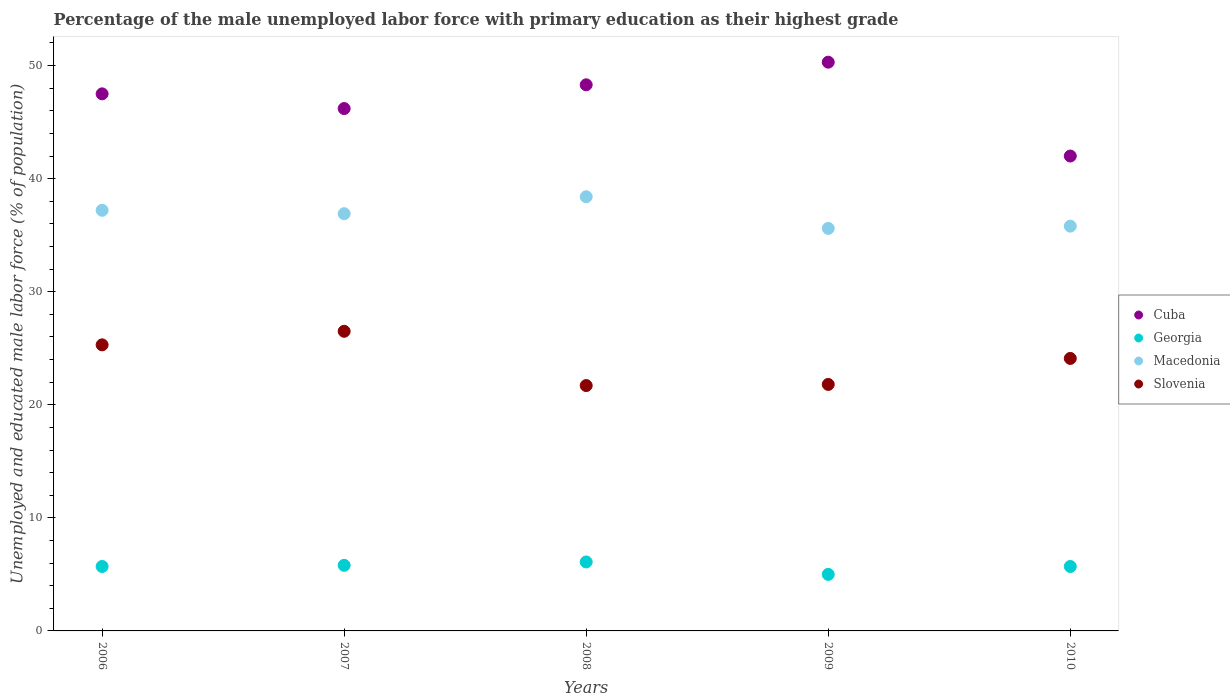How many different coloured dotlines are there?
Your answer should be very brief. 4. What is the percentage of the unemployed male labor force with primary education in Macedonia in 2010?
Offer a very short reply. 35.8. Across all years, what is the maximum percentage of the unemployed male labor force with primary education in Slovenia?
Offer a terse response. 26.5. Across all years, what is the minimum percentage of the unemployed male labor force with primary education in Georgia?
Your response must be concise. 5. What is the total percentage of the unemployed male labor force with primary education in Cuba in the graph?
Your answer should be compact. 234.3. What is the difference between the percentage of the unemployed male labor force with primary education in Macedonia in 2007 and that in 2010?
Keep it short and to the point. 1.1. What is the difference between the percentage of the unemployed male labor force with primary education in Georgia in 2010 and the percentage of the unemployed male labor force with primary education in Cuba in 2009?
Provide a succinct answer. -44.6. What is the average percentage of the unemployed male labor force with primary education in Macedonia per year?
Your answer should be compact. 36.78. In the year 2006, what is the difference between the percentage of the unemployed male labor force with primary education in Cuba and percentage of the unemployed male labor force with primary education in Macedonia?
Offer a very short reply. 10.3. In how many years, is the percentage of the unemployed male labor force with primary education in Georgia greater than 40 %?
Your response must be concise. 0. What is the ratio of the percentage of the unemployed male labor force with primary education in Georgia in 2006 to that in 2010?
Give a very brief answer. 1. Is the percentage of the unemployed male labor force with primary education in Slovenia in 2007 less than that in 2008?
Offer a terse response. No. What is the difference between the highest and the second highest percentage of the unemployed male labor force with primary education in Cuba?
Give a very brief answer. 2. What is the difference between the highest and the lowest percentage of the unemployed male labor force with primary education in Macedonia?
Provide a short and direct response. 2.8. In how many years, is the percentage of the unemployed male labor force with primary education in Cuba greater than the average percentage of the unemployed male labor force with primary education in Cuba taken over all years?
Provide a succinct answer. 3. Is the sum of the percentage of the unemployed male labor force with primary education in Slovenia in 2007 and 2010 greater than the maximum percentage of the unemployed male labor force with primary education in Cuba across all years?
Your answer should be very brief. Yes. Is it the case that in every year, the sum of the percentage of the unemployed male labor force with primary education in Georgia and percentage of the unemployed male labor force with primary education in Cuba  is greater than the percentage of the unemployed male labor force with primary education in Slovenia?
Make the answer very short. Yes. Does the percentage of the unemployed male labor force with primary education in Macedonia monotonically increase over the years?
Provide a succinct answer. No. How many dotlines are there?
Your answer should be compact. 4. What is the difference between two consecutive major ticks on the Y-axis?
Make the answer very short. 10. Does the graph contain grids?
Keep it short and to the point. No. How many legend labels are there?
Your answer should be very brief. 4. What is the title of the graph?
Keep it short and to the point. Percentage of the male unemployed labor force with primary education as their highest grade. Does "Croatia" appear as one of the legend labels in the graph?
Offer a terse response. No. What is the label or title of the X-axis?
Your answer should be compact. Years. What is the label or title of the Y-axis?
Give a very brief answer. Unemployed and educated male labor force (% of population). What is the Unemployed and educated male labor force (% of population) of Cuba in 2006?
Your answer should be compact. 47.5. What is the Unemployed and educated male labor force (% of population) in Georgia in 2006?
Make the answer very short. 5.7. What is the Unemployed and educated male labor force (% of population) of Macedonia in 2006?
Keep it short and to the point. 37.2. What is the Unemployed and educated male labor force (% of population) of Slovenia in 2006?
Offer a very short reply. 25.3. What is the Unemployed and educated male labor force (% of population) in Cuba in 2007?
Your response must be concise. 46.2. What is the Unemployed and educated male labor force (% of population) of Georgia in 2007?
Give a very brief answer. 5.8. What is the Unemployed and educated male labor force (% of population) of Macedonia in 2007?
Your response must be concise. 36.9. What is the Unemployed and educated male labor force (% of population) of Cuba in 2008?
Your answer should be compact. 48.3. What is the Unemployed and educated male labor force (% of population) in Georgia in 2008?
Provide a short and direct response. 6.1. What is the Unemployed and educated male labor force (% of population) in Macedonia in 2008?
Keep it short and to the point. 38.4. What is the Unemployed and educated male labor force (% of population) in Slovenia in 2008?
Give a very brief answer. 21.7. What is the Unemployed and educated male labor force (% of population) in Cuba in 2009?
Your response must be concise. 50.3. What is the Unemployed and educated male labor force (% of population) in Georgia in 2009?
Make the answer very short. 5. What is the Unemployed and educated male labor force (% of population) in Macedonia in 2009?
Offer a terse response. 35.6. What is the Unemployed and educated male labor force (% of population) in Slovenia in 2009?
Give a very brief answer. 21.8. What is the Unemployed and educated male labor force (% of population) of Cuba in 2010?
Offer a very short reply. 42. What is the Unemployed and educated male labor force (% of population) of Georgia in 2010?
Your answer should be compact. 5.7. What is the Unemployed and educated male labor force (% of population) of Macedonia in 2010?
Give a very brief answer. 35.8. What is the Unemployed and educated male labor force (% of population) of Slovenia in 2010?
Make the answer very short. 24.1. Across all years, what is the maximum Unemployed and educated male labor force (% of population) of Cuba?
Offer a very short reply. 50.3. Across all years, what is the maximum Unemployed and educated male labor force (% of population) of Georgia?
Your response must be concise. 6.1. Across all years, what is the maximum Unemployed and educated male labor force (% of population) in Macedonia?
Give a very brief answer. 38.4. Across all years, what is the minimum Unemployed and educated male labor force (% of population) in Cuba?
Your response must be concise. 42. Across all years, what is the minimum Unemployed and educated male labor force (% of population) in Macedonia?
Make the answer very short. 35.6. Across all years, what is the minimum Unemployed and educated male labor force (% of population) in Slovenia?
Offer a terse response. 21.7. What is the total Unemployed and educated male labor force (% of population) in Cuba in the graph?
Make the answer very short. 234.3. What is the total Unemployed and educated male labor force (% of population) of Georgia in the graph?
Make the answer very short. 28.3. What is the total Unemployed and educated male labor force (% of population) of Macedonia in the graph?
Offer a terse response. 183.9. What is the total Unemployed and educated male labor force (% of population) in Slovenia in the graph?
Keep it short and to the point. 119.4. What is the difference between the Unemployed and educated male labor force (% of population) in Georgia in 2006 and that in 2007?
Provide a succinct answer. -0.1. What is the difference between the Unemployed and educated male labor force (% of population) of Macedonia in 2006 and that in 2007?
Offer a very short reply. 0.3. What is the difference between the Unemployed and educated male labor force (% of population) in Slovenia in 2006 and that in 2007?
Keep it short and to the point. -1.2. What is the difference between the Unemployed and educated male labor force (% of population) of Cuba in 2006 and that in 2008?
Make the answer very short. -0.8. What is the difference between the Unemployed and educated male labor force (% of population) in Georgia in 2006 and that in 2008?
Offer a terse response. -0.4. What is the difference between the Unemployed and educated male labor force (% of population) in Slovenia in 2006 and that in 2008?
Offer a very short reply. 3.6. What is the difference between the Unemployed and educated male labor force (% of population) of Georgia in 2006 and that in 2009?
Ensure brevity in your answer.  0.7. What is the difference between the Unemployed and educated male labor force (% of population) of Cuba in 2006 and that in 2010?
Ensure brevity in your answer.  5.5. What is the difference between the Unemployed and educated male labor force (% of population) in Macedonia in 2006 and that in 2010?
Provide a short and direct response. 1.4. What is the difference between the Unemployed and educated male labor force (% of population) in Georgia in 2007 and that in 2008?
Make the answer very short. -0.3. What is the difference between the Unemployed and educated male labor force (% of population) in Macedonia in 2007 and that in 2008?
Your answer should be compact. -1.5. What is the difference between the Unemployed and educated male labor force (% of population) of Cuba in 2007 and that in 2009?
Make the answer very short. -4.1. What is the difference between the Unemployed and educated male labor force (% of population) of Georgia in 2007 and that in 2009?
Your response must be concise. 0.8. What is the difference between the Unemployed and educated male labor force (% of population) of Macedonia in 2007 and that in 2009?
Make the answer very short. 1.3. What is the difference between the Unemployed and educated male labor force (% of population) of Cuba in 2007 and that in 2010?
Make the answer very short. 4.2. What is the difference between the Unemployed and educated male labor force (% of population) of Slovenia in 2007 and that in 2010?
Ensure brevity in your answer.  2.4. What is the difference between the Unemployed and educated male labor force (% of population) of Cuba in 2008 and that in 2009?
Provide a short and direct response. -2. What is the difference between the Unemployed and educated male labor force (% of population) of Macedonia in 2008 and that in 2009?
Provide a short and direct response. 2.8. What is the difference between the Unemployed and educated male labor force (% of population) in Slovenia in 2008 and that in 2009?
Your answer should be very brief. -0.1. What is the difference between the Unemployed and educated male labor force (% of population) in Cuba in 2008 and that in 2010?
Your answer should be very brief. 6.3. What is the difference between the Unemployed and educated male labor force (% of population) in Macedonia in 2008 and that in 2010?
Provide a short and direct response. 2.6. What is the difference between the Unemployed and educated male labor force (% of population) in Slovenia in 2008 and that in 2010?
Keep it short and to the point. -2.4. What is the difference between the Unemployed and educated male labor force (% of population) in Cuba in 2009 and that in 2010?
Provide a succinct answer. 8.3. What is the difference between the Unemployed and educated male labor force (% of population) in Slovenia in 2009 and that in 2010?
Offer a terse response. -2.3. What is the difference between the Unemployed and educated male labor force (% of population) in Cuba in 2006 and the Unemployed and educated male labor force (% of population) in Georgia in 2007?
Keep it short and to the point. 41.7. What is the difference between the Unemployed and educated male labor force (% of population) of Georgia in 2006 and the Unemployed and educated male labor force (% of population) of Macedonia in 2007?
Make the answer very short. -31.2. What is the difference between the Unemployed and educated male labor force (% of population) in Georgia in 2006 and the Unemployed and educated male labor force (% of population) in Slovenia in 2007?
Keep it short and to the point. -20.8. What is the difference between the Unemployed and educated male labor force (% of population) in Cuba in 2006 and the Unemployed and educated male labor force (% of population) in Georgia in 2008?
Offer a terse response. 41.4. What is the difference between the Unemployed and educated male labor force (% of population) in Cuba in 2006 and the Unemployed and educated male labor force (% of population) in Slovenia in 2008?
Keep it short and to the point. 25.8. What is the difference between the Unemployed and educated male labor force (% of population) in Georgia in 2006 and the Unemployed and educated male labor force (% of population) in Macedonia in 2008?
Provide a short and direct response. -32.7. What is the difference between the Unemployed and educated male labor force (% of population) in Georgia in 2006 and the Unemployed and educated male labor force (% of population) in Slovenia in 2008?
Provide a succinct answer. -16. What is the difference between the Unemployed and educated male labor force (% of population) of Cuba in 2006 and the Unemployed and educated male labor force (% of population) of Georgia in 2009?
Your response must be concise. 42.5. What is the difference between the Unemployed and educated male labor force (% of population) of Cuba in 2006 and the Unemployed and educated male labor force (% of population) of Slovenia in 2009?
Your answer should be compact. 25.7. What is the difference between the Unemployed and educated male labor force (% of population) of Georgia in 2006 and the Unemployed and educated male labor force (% of population) of Macedonia in 2009?
Offer a very short reply. -29.9. What is the difference between the Unemployed and educated male labor force (% of population) of Georgia in 2006 and the Unemployed and educated male labor force (% of population) of Slovenia in 2009?
Your answer should be very brief. -16.1. What is the difference between the Unemployed and educated male labor force (% of population) of Cuba in 2006 and the Unemployed and educated male labor force (% of population) of Georgia in 2010?
Offer a terse response. 41.8. What is the difference between the Unemployed and educated male labor force (% of population) in Cuba in 2006 and the Unemployed and educated male labor force (% of population) in Macedonia in 2010?
Your response must be concise. 11.7. What is the difference between the Unemployed and educated male labor force (% of population) of Cuba in 2006 and the Unemployed and educated male labor force (% of population) of Slovenia in 2010?
Make the answer very short. 23.4. What is the difference between the Unemployed and educated male labor force (% of population) in Georgia in 2006 and the Unemployed and educated male labor force (% of population) in Macedonia in 2010?
Keep it short and to the point. -30.1. What is the difference between the Unemployed and educated male labor force (% of population) of Georgia in 2006 and the Unemployed and educated male labor force (% of population) of Slovenia in 2010?
Offer a terse response. -18.4. What is the difference between the Unemployed and educated male labor force (% of population) of Macedonia in 2006 and the Unemployed and educated male labor force (% of population) of Slovenia in 2010?
Offer a terse response. 13.1. What is the difference between the Unemployed and educated male labor force (% of population) of Cuba in 2007 and the Unemployed and educated male labor force (% of population) of Georgia in 2008?
Provide a short and direct response. 40.1. What is the difference between the Unemployed and educated male labor force (% of population) in Cuba in 2007 and the Unemployed and educated male labor force (% of population) in Macedonia in 2008?
Your answer should be compact. 7.8. What is the difference between the Unemployed and educated male labor force (% of population) of Cuba in 2007 and the Unemployed and educated male labor force (% of population) of Slovenia in 2008?
Provide a succinct answer. 24.5. What is the difference between the Unemployed and educated male labor force (% of population) of Georgia in 2007 and the Unemployed and educated male labor force (% of population) of Macedonia in 2008?
Your response must be concise. -32.6. What is the difference between the Unemployed and educated male labor force (% of population) of Georgia in 2007 and the Unemployed and educated male labor force (% of population) of Slovenia in 2008?
Provide a short and direct response. -15.9. What is the difference between the Unemployed and educated male labor force (% of population) in Macedonia in 2007 and the Unemployed and educated male labor force (% of population) in Slovenia in 2008?
Give a very brief answer. 15.2. What is the difference between the Unemployed and educated male labor force (% of population) of Cuba in 2007 and the Unemployed and educated male labor force (% of population) of Georgia in 2009?
Your answer should be compact. 41.2. What is the difference between the Unemployed and educated male labor force (% of population) of Cuba in 2007 and the Unemployed and educated male labor force (% of population) of Macedonia in 2009?
Offer a terse response. 10.6. What is the difference between the Unemployed and educated male labor force (% of population) of Cuba in 2007 and the Unemployed and educated male labor force (% of population) of Slovenia in 2009?
Your answer should be very brief. 24.4. What is the difference between the Unemployed and educated male labor force (% of population) of Georgia in 2007 and the Unemployed and educated male labor force (% of population) of Macedonia in 2009?
Your answer should be very brief. -29.8. What is the difference between the Unemployed and educated male labor force (% of population) of Macedonia in 2007 and the Unemployed and educated male labor force (% of population) of Slovenia in 2009?
Keep it short and to the point. 15.1. What is the difference between the Unemployed and educated male labor force (% of population) of Cuba in 2007 and the Unemployed and educated male labor force (% of population) of Georgia in 2010?
Your answer should be compact. 40.5. What is the difference between the Unemployed and educated male labor force (% of population) of Cuba in 2007 and the Unemployed and educated male labor force (% of population) of Macedonia in 2010?
Your answer should be compact. 10.4. What is the difference between the Unemployed and educated male labor force (% of population) in Cuba in 2007 and the Unemployed and educated male labor force (% of population) in Slovenia in 2010?
Offer a very short reply. 22.1. What is the difference between the Unemployed and educated male labor force (% of population) of Georgia in 2007 and the Unemployed and educated male labor force (% of population) of Macedonia in 2010?
Give a very brief answer. -30. What is the difference between the Unemployed and educated male labor force (% of population) in Georgia in 2007 and the Unemployed and educated male labor force (% of population) in Slovenia in 2010?
Offer a very short reply. -18.3. What is the difference between the Unemployed and educated male labor force (% of population) of Cuba in 2008 and the Unemployed and educated male labor force (% of population) of Georgia in 2009?
Keep it short and to the point. 43.3. What is the difference between the Unemployed and educated male labor force (% of population) in Georgia in 2008 and the Unemployed and educated male labor force (% of population) in Macedonia in 2009?
Offer a very short reply. -29.5. What is the difference between the Unemployed and educated male labor force (% of population) in Georgia in 2008 and the Unemployed and educated male labor force (% of population) in Slovenia in 2009?
Your answer should be compact. -15.7. What is the difference between the Unemployed and educated male labor force (% of population) of Macedonia in 2008 and the Unemployed and educated male labor force (% of population) of Slovenia in 2009?
Ensure brevity in your answer.  16.6. What is the difference between the Unemployed and educated male labor force (% of population) in Cuba in 2008 and the Unemployed and educated male labor force (% of population) in Georgia in 2010?
Provide a succinct answer. 42.6. What is the difference between the Unemployed and educated male labor force (% of population) of Cuba in 2008 and the Unemployed and educated male labor force (% of population) of Macedonia in 2010?
Your answer should be very brief. 12.5. What is the difference between the Unemployed and educated male labor force (% of population) of Cuba in 2008 and the Unemployed and educated male labor force (% of population) of Slovenia in 2010?
Provide a short and direct response. 24.2. What is the difference between the Unemployed and educated male labor force (% of population) of Georgia in 2008 and the Unemployed and educated male labor force (% of population) of Macedonia in 2010?
Keep it short and to the point. -29.7. What is the difference between the Unemployed and educated male labor force (% of population) of Georgia in 2008 and the Unemployed and educated male labor force (% of population) of Slovenia in 2010?
Your answer should be compact. -18. What is the difference between the Unemployed and educated male labor force (% of population) in Macedonia in 2008 and the Unemployed and educated male labor force (% of population) in Slovenia in 2010?
Give a very brief answer. 14.3. What is the difference between the Unemployed and educated male labor force (% of population) of Cuba in 2009 and the Unemployed and educated male labor force (% of population) of Georgia in 2010?
Keep it short and to the point. 44.6. What is the difference between the Unemployed and educated male labor force (% of population) of Cuba in 2009 and the Unemployed and educated male labor force (% of population) of Slovenia in 2010?
Offer a very short reply. 26.2. What is the difference between the Unemployed and educated male labor force (% of population) of Georgia in 2009 and the Unemployed and educated male labor force (% of population) of Macedonia in 2010?
Provide a short and direct response. -30.8. What is the difference between the Unemployed and educated male labor force (% of population) in Georgia in 2009 and the Unemployed and educated male labor force (% of population) in Slovenia in 2010?
Offer a very short reply. -19.1. What is the average Unemployed and educated male labor force (% of population) in Cuba per year?
Your answer should be very brief. 46.86. What is the average Unemployed and educated male labor force (% of population) of Georgia per year?
Your answer should be compact. 5.66. What is the average Unemployed and educated male labor force (% of population) in Macedonia per year?
Offer a terse response. 36.78. What is the average Unemployed and educated male labor force (% of population) in Slovenia per year?
Your answer should be very brief. 23.88. In the year 2006, what is the difference between the Unemployed and educated male labor force (% of population) of Cuba and Unemployed and educated male labor force (% of population) of Georgia?
Offer a terse response. 41.8. In the year 2006, what is the difference between the Unemployed and educated male labor force (% of population) in Cuba and Unemployed and educated male labor force (% of population) in Macedonia?
Offer a terse response. 10.3. In the year 2006, what is the difference between the Unemployed and educated male labor force (% of population) in Georgia and Unemployed and educated male labor force (% of population) in Macedonia?
Ensure brevity in your answer.  -31.5. In the year 2006, what is the difference between the Unemployed and educated male labor force (% of population) of Georgia and Unemployed and educated male labor force (% of population) of Slovenia?
Offer a very short reply. -19.6. In the year 2006, what is the difference between the Unemployed and educated male labor force (% of population) in Macedonia and Unemployed and educated male labor force (% of population) in Slovenia?
Make the answer very short. 11.9. In the year 2007, what is the difference between the Unemployed and educated male labor force (% of population) of Cuba and Unemployed and educated male labor force (% of population) of Georgia?
Make the answer very short. 40.4. In the year 2007, what is the difference between the Unemployed and educated male labor force (% of population) in Cuba and Unemployed and educated male labor force (% of population) in Macedonia?
Provide a succinct answer. 9.3. In the year 2007, what is the difference between the Unemployed and educated male labor force (% of population) in Cuba and Unemployed and educated male labor force (% of population) in Slovenia?
Provide a short and direct response. 19.7. In the year 2007, what is the difference between the Unemployed and educated male labor force (% of population) in Georgia and Unemployed and educated male labor force (% of population) in Macedonia?
Your response must be concise. -31.1. In the year 2007, what is the difference between the Unemployed and educated male labor force (% of population) in Georgia and Unemployed and educated male labor force (% of population) in Slovenia?
Provide a succinct answer. -20.7. In the year 2007, what is the difference between the Unemployed and educated male labor force (% of population) in Macedonia and Unemployed and educated male labor force (% of population) in Slovenia?
Offer a terse response. 10.4. In the year 2008, what is the difference between the Unemployed and educated male labor force (% of population) in Cuba and Unemployed and educated male labor force (% of population) in Georgia?
Ensure brevity in your answer.  42.2. In the year 2008, what is the difference between the Unemployed and educated male labor force (% of population) of Cuba and Unemployed and educated male labor force (% of population) of Macedonia?
Your response must be concise. 9.9. In the year 2008, what is the difference between the Unemployed and educated male labor force (% of population) in Cuba and Unemployed and educated male labor force (% of population) in Slovenia?
Provide a short and direct response. 26.6. In the year 2008, what is the difference between the Unemployed and educated male labor force (% of population) of Georgia and Unemployed and educated male labor force (% of population) of Macedonia?
Your answer should be very brief. -32.3. In the year 2008, what is the difference between the Unemployed and educated male labor force (% of population) in Georgia and Unemployed and educated male labor force (% of population) in Slovenia?
Provide a succinct answer. -15.6. In the year 2009, what is the difference between the Unemployed and educated male labor force (% of population) of Cuba and Unemployed and educated male labor force (% of population) of Georgia?
Your response must be concise. 45.3. In the year 2009, what is the difference between the Unemployed and educated male labor force (% of population) in Cuba and Unemployed and educated male labor force (% of population) in Macedonia?
Give a very brief answer. 14.7. In the year 2009, what is the difference between the Unemployed and educated male labor force (% of population) in Georgia and Unemployed and educated male labor force (% of population) in Macedonia?
Provide a succinct answer. -30.6. In the year 2009, what is the difference between the Unemployed and educated male labor force (% of population) in Georgia and Unemployed and educated male labor force (% of population) in Slovenia?
Provide a succinct answer. -16.8. In the year 2010, what is the difference between the Unemployed and educated male labor force (% of population) in Cuba and Unemployed and educated male labor force (% of population) in Georgia?
Give a very brief answer. 36.3. In the year 2010, what is the difference between the Unemployed and educated male labor force (% of population) in Cuba and Unemployed and educated male labor force (% of population) in Macedonia?
Your response must be concise. 6.2. In the year 2010, what is the difference between the Unemployed and educated male labor force (% of population) in Cuba and Unemployed and educated male labor force (% of population) in Slovenia?
Make the answer very short. 17.9. In the year 2010, what is the difference between the Unemployed and educated male labor force (% of population) in Georgia and Unemployed and educated male labor force (% of population) in Macedonia?
Offer a very short reply. -30.1. In the year 2010, what is the difference between the Unemployed and educated male labor force (% of population) of Georgia and Unemployed and educated male labor force (% of population) of Slovenia?
Make the answer very short. -18.4. In the year 2010, what is the difference between the Unemployed and educated male labor force (% of population) of Macedonia and Unemployed and educated male labor force (% of population) of Slovenia?
Your answer should be very brief. 11.7. What is the ratio of the Unemployed and educated male labor force (% of population) of Cuba in 2006 to that in 2007?
Your response must be concise. 1.03. What is the ratio of the Unemployed and educated male labor force (% of population) of Georgia in 2006 to that in 2007?
Keep it short and to the point. 0.98. What is the ratio of the Unemployed and educated male labor force (% of population) in Slovenia in 2006 to that in 2007?
Provide a succinct answer. 0.95. What is the ratio of the Unemployed and educated male labor force (% of population) of Cuba in 2006 to that in 2008?
Make the answer very short. 0.98. What is the ratio of the Unemployed and educated male labor force (% of population) of Georgia in 2006 to that in 2008?
Give a very brief answer. 0.93. What is the ratio of the Unemployed and educated male labor force (% of population) of Macedonia in 2006 to that in 2008?
Offer a very short reply. 0.97. What is the ratio of the Unemployed and educated male labor force (% of population) of Slovenia in 2006 to that in 2008?
Offer a terse response. 1.17. What is the ratio of the Unemployed and educated male labor force (% of population) in Cuba in 2006 to that in 2009?
Ensure brevity in your answer.  0.94. What is the ratio of the Unemployed and educated male labor force (% of population) of Georgia in 2006 to that in 2009?
Keep it short and to the point. 1.14. What is the ratio of the Unemployed and educated male labor force (% of population) in Macedonia in 2006 to that in 2009?
Your answer should be very brief. 1.04. What is the ratio of the Unemployed and educated male labor force (% of population) of Slovenia in 2006 to that in 2009?
Provide a succinct answer. 1.16. What is the ratio of the Unemployed and educated male labor force (% of population) of Cuba in 2006 to that in 2010?
Ensure brevity in your answer.  1.13. What is the ratio of the Unemployed and educated male labor force (% of population) in Georgia in 2006 to that in 2010?
Give a very brief answer. 1. What is the ratio of the Unemployed and educated male labor force (% of population) of Macedonia in 2006 to that in 2010?
Keep it short and to the point. 1.04. What is the ratio of the Unemployed and educated male labor force (% of population) of Slovenia in 2006 to that in 2010?
Make the answer very short. 1.05. What is the ratio of the Unemployed and educated male labor force (% of population) in Cuba in 2007 to that in 2008?
Give a very brief answer. 0.96. What is the ratio of the Unemployed and educated male labor force (% of population) of Georgia in 2007 to that in 2008?
Provide a short and direct response. 0.95. What is the ratio of the Unemployed and educated male labor force (% of population) of Macedonia in 2007 to that in 2008?
Make the answer very short. 0.96. What is the ratio of the Unemployed and educated male labor force (% of population) in Slovenia in 2007 to that in 2008?
Your answer should be compact. 1.22. What is the ratio of the Unemployed and educated male labor force (% of population) of Cuba in 2007 to that in 2009?
Give a very brief answer. 0.92. What is the ratio of the Unemployed and educated male labor force (% of population) in Georgia in 2007 to that in 2009?
Make the answer very short. 1.16. What is the ratio of the Unemployed and educated male labor force (% of population) of Macedonia in 2007 to that in 2009?
Provide a succinct answer. 1.04. What is the ratio of the Unemployed and educated male labor force (% of population) in Slovenia in 2007 to that in 2009?
Provide a short and direct response. 1.22. What is the ratio of the Unemployed and educated male labor force (% of population) in Georgia in 2007 to that in 2010?
Provide a short and direct response. 1.02. What is the ratio of the Unemployed and educated male labor force (% of population) in Macedonia in 2007 to that in 2010?
Keep it short and to the point. 1.03. What is the ratio of the Unemployed and educated male labor force (% of population) in Slovenia in 2007 to that in 2010?
Give a very brief answer. 1.1. What is the ratio of the Unemployed and educated male labor force (% of population) in Cuba in 2008 to that in 2009?
Keep it short and to the point. 0.96. What is the ratio of the Unemployed and educated male labor force (% of population) of Georgia in 2008 to that in 2009?
Provide a succinct answer. 1.22. What is the ratio of the Unemployed and educated male labor force (% of population) in Macedonia in 2008 to that in 2009?
Keep it short and to the point. 1.08. What is the ratio of the Unemployed and educated male labor force (% of population) in Cuba in 2008 to that in 2010?
Make the answer very short. 1.15. What is the ratio of the Unemployed and educated male labor force (% of population) of Georgia in 2008 to that in 2010?
Your answer should be very brief. 1.07. What is the ratio of the Unemployed and educated male labor force (% of population) of Macedonia in 2008 to that in 2010?
Your answer should be very brief. 1.07. What is the ratio of the Unemployed and educated male labor force (% of population) of Slovenia in 2008 to that in 2010?
Your answer should be very brief. 0.9. What is the ratio of the Unemployed and educated male labor force (% of population) in Cuba in 2009 to that in 2010?
Provide a succinct answer. 1.2. What is the ratio of the Unemployed and educated male labor force (% of population) in Georgia in 2009 to that in 2010?
Provide a succinct answer. 0.88. What is the ratio of the Unemployed and educated male labor force (% of population) in Macedonia in 2009 to that in 2010?
Provide a succinct answer. 0.99. What is the ratio of the Unemployed and educated male labor force (% of population) of Slovenia in 2009 to that in 2010?
Your response must be concise. 0.9. What is the difference between the highest and the second highest Unemployed and educated male labor force (% of population) of Cuba?
Provide a succinct answer. 2. What is the difference between the highest and the second highest Unemployed and educated male labor force (% of population) of Georgia?
Ensure brevity in your answer.  0.3. What is the difference between the highest and the second highest Unemployed and educated male labor force (% of population) of Slovenia?
Your response must be concise. 1.2. What is the difference between the highest and the lowest Unemployed and educated male labor force (% of population) in Cuba?
Your response must be concise. 8.3. What is the difference between the highest and the lowest Unemployed and educated male labor force (% of population) of Georgia?
Provide a short and direct response. 1.1. 